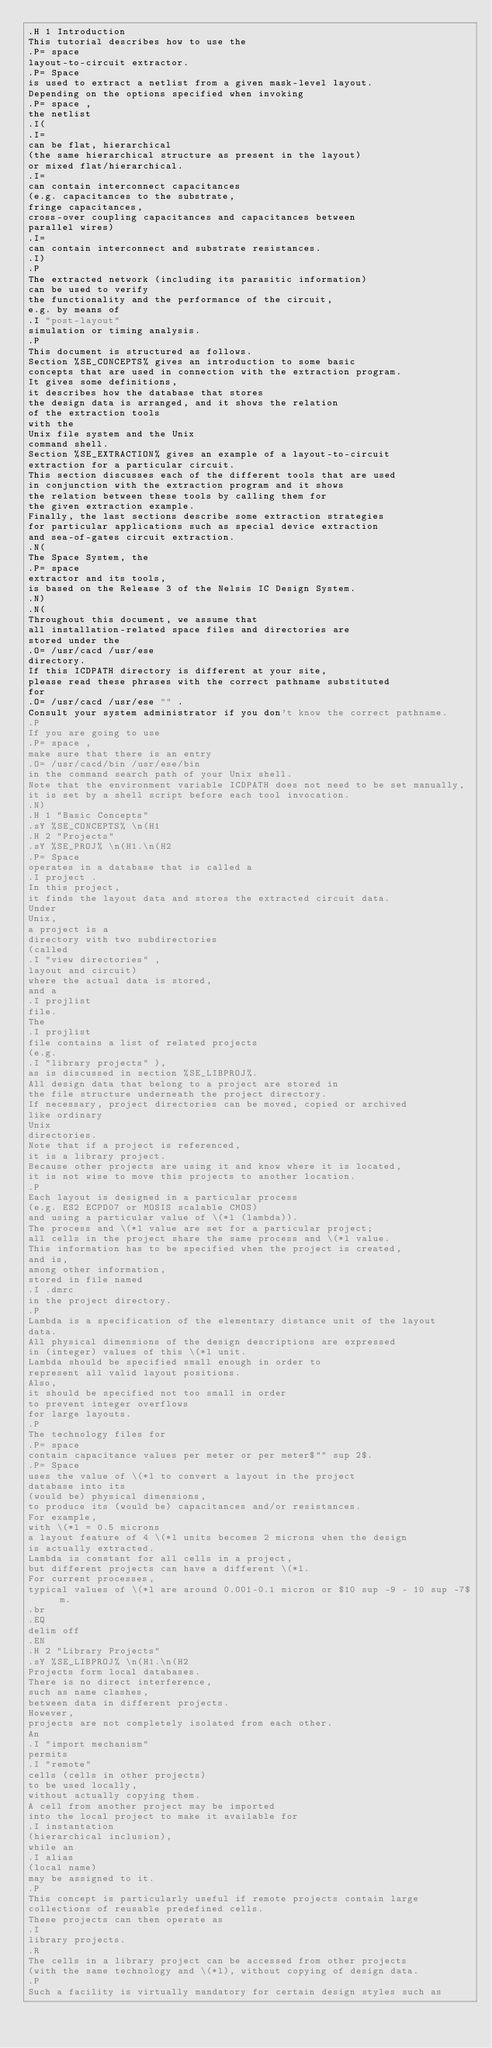<code> <loc_0><loc_0><loc_500><loc_500><_ObjectiveC_>.H 1 Introduction
This tutorial describes how to use the
.P= space
layout-to-circuit extractor.
.P= Space
is used to extract a netlist from a given mask-level layout.
Depending on the options specified when invoking
.P= space ,
the netlist
.I(
.I=
can be flat, hierarchical
(the same hierarchical structure as present in the layout)
or mixed flat/hierarchical.
.I=
can contain interconnect capacitances
(e.g. capacitances to the substrate,
fringe capacitances,
cross-over coupling capacitances and capacitances between
parallel wires)
.I=
can contain interconnect and substrate resistances.
.I)
.P
The extracted network (including its parasitic information)
can be used to verify
the functionality and the performance of the circuit,
e.g. by means of
.I "post-layout"
simulation or timing analysis.
.P
This document is structured as follows.
Section %SE_CONCEPTS% gives an introduction to some basic
concepts that are used in connection with the extraction program.
It gives some definitions,
it describes how the database that stores
the design data is arranged, and it shows the relation
of the extraction tools
with the
Unix file system and the Unix
command shell.
Section %SE_EXTRACTION% gives an example of a layout-to-circuit
extraction for a particular circuit.
This section discusses each of the different tools that are used
in conjunction with the extraction program and it shows
the relation between these tools by calling them for
the given extraction example.
Finally, the last sections describe some extraction strategies
for particular applications such as special device extraction
and sea-of-gates circuit extraction.
.N(
The Space System, the
.P= space
extractor and its tools,
is based on the Release 3 of the Nelsis IC Design System.
.N)
.N(
Throughout this document, we assume that 
all installation-related space files and directories are
stored under the
.O= /usr/cacd /usr/ese
directory.
If this ICDPATH directory is different at your site,
please read these phrases with the correct pathname substituted
for
.O= /usr/cacd /usr/ese "" .
Consult your system administrator if you don't know the correct pathname.
.P
If you are going to use
.P= space ,
make sure that there is an entry
.O= /usr/cacd/bin /usr/ese/bin
in the command search path of your Unix shell.
Note that the environment variable ICDPATH does not need to be set manually,
it is set by a shell script before each tool invocation.
.N)
.H 1 "Basic Concepts"
.sY %SE_CONCEPTS% \n(H1
.H 2 "Projects"
.sY %SE_PROJ% \n(H1.\n(H2
.P= Space
operates in a database that is called a
.I project .
In this project,
it finds the layout data and stores the extracted circuit data.
Under
Unix,
a project is a
directory with two subdirectories
(called 
.I "view directories" ,
layout and circuit)
where the actual data is stored,
and a
.I projlist
file.
The
.I projlist
file contains a list of related projects
(e.g. 
.I "library projects" ),
as is discussed in section %SE_LIBPROJ%.
All design data that belong to a project are stored in
the file structure underneath the project directory.
If necessary, project directories can be moved, copied or archived
like ordinary
Unix
directories.
Note that if a project is referenced,
it is a library project.
Because other projects are using it and know where it is located,
it is not wise to move this projects to another location.
.P
Each layout is designed in a particular process
(e.g. ES2 ECPD07 or MOSIS scalable CMOS)
and using a particular value of \(*l (lambda)).
The process and \(*l value are set for a particular project;
all cells in the project share the same process and \(*l value.
This information has to be specified when the project is created,
and is,
among other information,
stored in file named
.I .dmrc
in the project directory.
.P
Lambda is a specification of the elementary distance unit of the layout
data.
All physical dimensions of the design descriptions are expressed
in (integer) values of this \(*l unit.
Lambda should be specified small enough in order to
represent all valid layout positions.
Also,
it should be specified not too small in order
to prevent integer overflows
for large layouts.
.P
The technology files for
.P= space
contain capacitance values per meter or per meter$"" sup 2$.
.P= Space
uses the value of \(*l to convert a layout in the project
database into its
(would be) physical dimensions,
to produce its (would be) capacitances and/or resistances.
For example,
with \(*l = 0.5 microns
a layout feature of 4 \(*l units becomes 2 microns when the design
is actually extracted.
Lambda is constant for all cells in a project,
but different projects can have a different \(*l.
For current processes,
typical values of \(*l are around 0.001-0.1 micron or $10 sup -9 - 10 sup -7$ m.
.br
.EQ
delim off
.EN
.H 2 "Library Projects"
.sY %SE_LIBPROJ% \n(H1.\n(H2
Projects form local databases.
There is no direct interference,
such as name clashes,
between data in different projects.
However,
projects are not completely isolated from each other.
An 
.I "import mechanism"
permits
.I "remote"
cells (cells in other projects)
to be used locally,
without actually copying them.
A cell from another project may be imported
into the local project to make it available for
.I instantation
(hierarchical inclusion),
while an
.I alias
(local name)
may be assigned to it.
.P
This concept is particularly useful if remote projects contain large 
collections of reusable predefined cells.
These projects can then operate as
.I
library projects.
.R
The cells in a library project can be accessed from other projects
(with the same technology and \(*l), without copying of design data.
.P
Such a facility is virtually mandatory for certain design styles such as</code> 